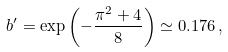<formula> <loc_0><loc_0><loc_500><loc_500>b ^ { \prime } = \exp \left ( - \frac { \pi ^ { 2 } + 4 } { 8 } \right ) \simeq 0 . 1 7 6 \, ,</formula> 